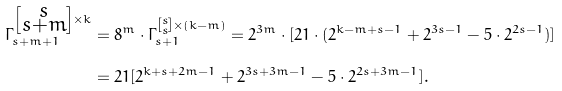<formula> <loc_0><loc_0><loc_500><loc_500>\Gamma _ { s + m + 1 } ^ { \left [ \substack { s \\ s + m } \right ] \times k } & = 8 ^ { m } \cdot \Gamma _ { s + 1 } ^ { \left [ \substack { s \\ s } \right ] \times ( k - m ) } = 2 ^ { 3 m } \cdot [ 2 1 \cdot ( 2 ^ { k - m + s - 1 } + 2 ^ { 3 s - 1 } - 5 \cdot 2 ^ { 2 s - 1 } ) ] \\ & = 2 1 [ 2 ^ { k + s + 2 m - 1 } + 2 ^ { 3 s + 3 m - 1 } - 5 \cdot 2 ^ { 2 s + 3 m - 1 } ] .</formula> 